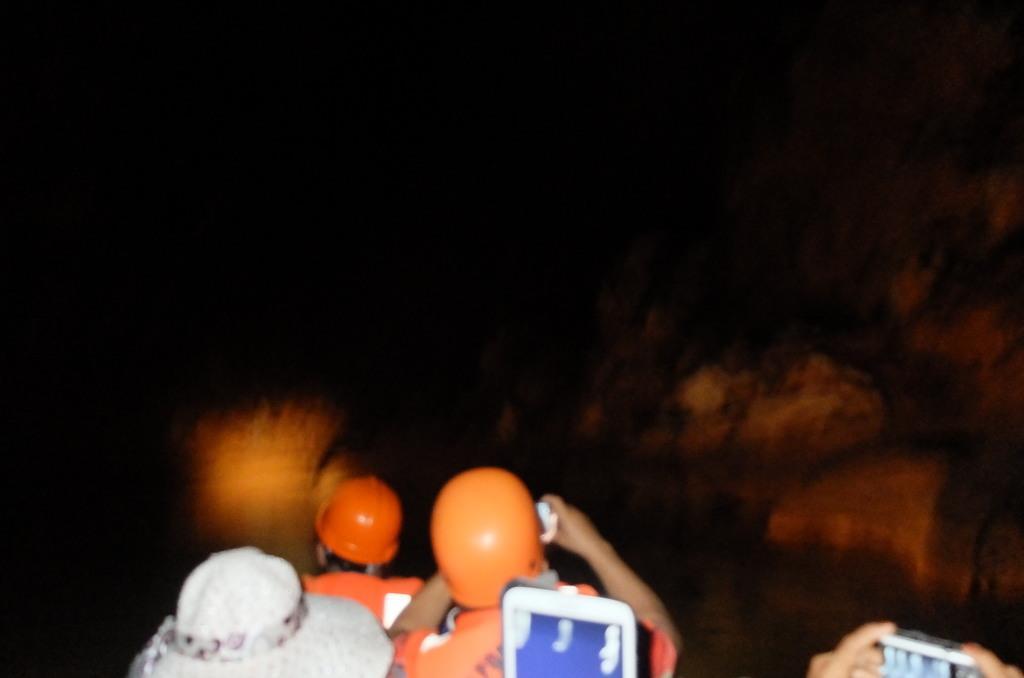Describe this image in one or two sentences. In this image there are people sitting and holding few objects in their hands, in the background it is dark. 